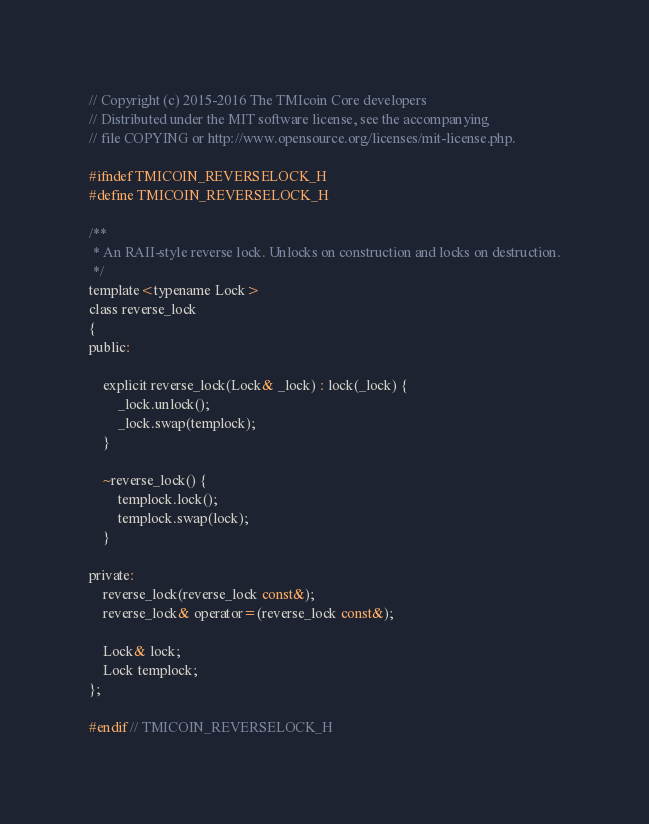<code> <loc_0><loc_0><loc_500><loc_500><_C_>// Copyright (c) 2015-2016 The TMIcoin Core developers
// Distributed under the MIT software license, see the accompanying
// file COPYING or http://www.opensource.org/licenses/mit-license.php.

#ifndef TMICOIN_REVERSELOCK_H
#define TMICOIN_REVERSELOCK_H

/**
 * An RAII-style reverse lock. Unlocks on construction and locks on destruction.
 */
template<typename Lock>
class reverse_lock
{
public:

    explicit reverse_lock(Lock& _lock) : lock(_lock) {
        _lock.unlock();
        _lock.swap(templock);
    }

    ~reverse_lock() {
        templock.lock();
        templock.swap(lock);
    }

private:
    reverse_lock(reverse_lock const&);
    reverse_lock& operator=(reverse_lock const&);

    Lock& lock;
    Lock templock;
};

#endif // TMICOIN_REVERSELOCK_H
</code> 